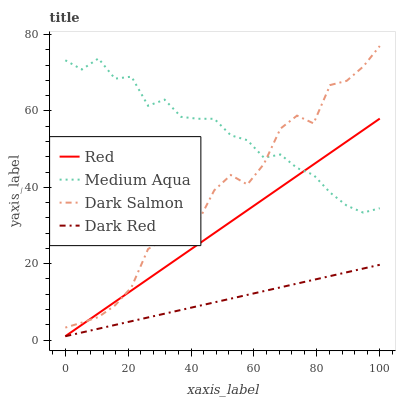Does Dark Red have the minimum area under the curve?
Answer yes or no. Yes. Does Medium Aqua have the maximum area under the curve?
Answer yes or no. Yes. Does Dark Salmon have the minimum area under the curve?
Answer yes or no. No. Does Dark Salmon have the maximum area under the curve?
Answer yes or no. No. Is Dark Red the smoothest?
Answer yes or no. Yes. Is Dark Salmon the roughest?
Answer yes or no. Yes. Is Medium Aqua the smoothest?
Answer yes or no. No. Is Medium Aqua the roughest?
Answer yes or no. No. Does Dark Salmon have the lowest value?
Answer yes or no. No. Does Dark Salmon have the highest value?
Answer yes or no. Yes. Does Medium Aqua have the highest value?
Answer yes or no. No. Is Dark Red less than Dark Salmon?
Answer yes or no. Yes. Is Dark Salmon greater than Dark Red?
Answer yes or no. Yes. Does Dark Salmon intersect Medium Aqua?
Answer yes or no. Yes. Is Dark Salmon less than Medium Aqua?
Answer yes or no. No. Is Dark Salmon greater than Medium Aqua?
Answer yes or no. No. Does Dark Red intersect Dark Salmon?
Answer yes or no. No. 